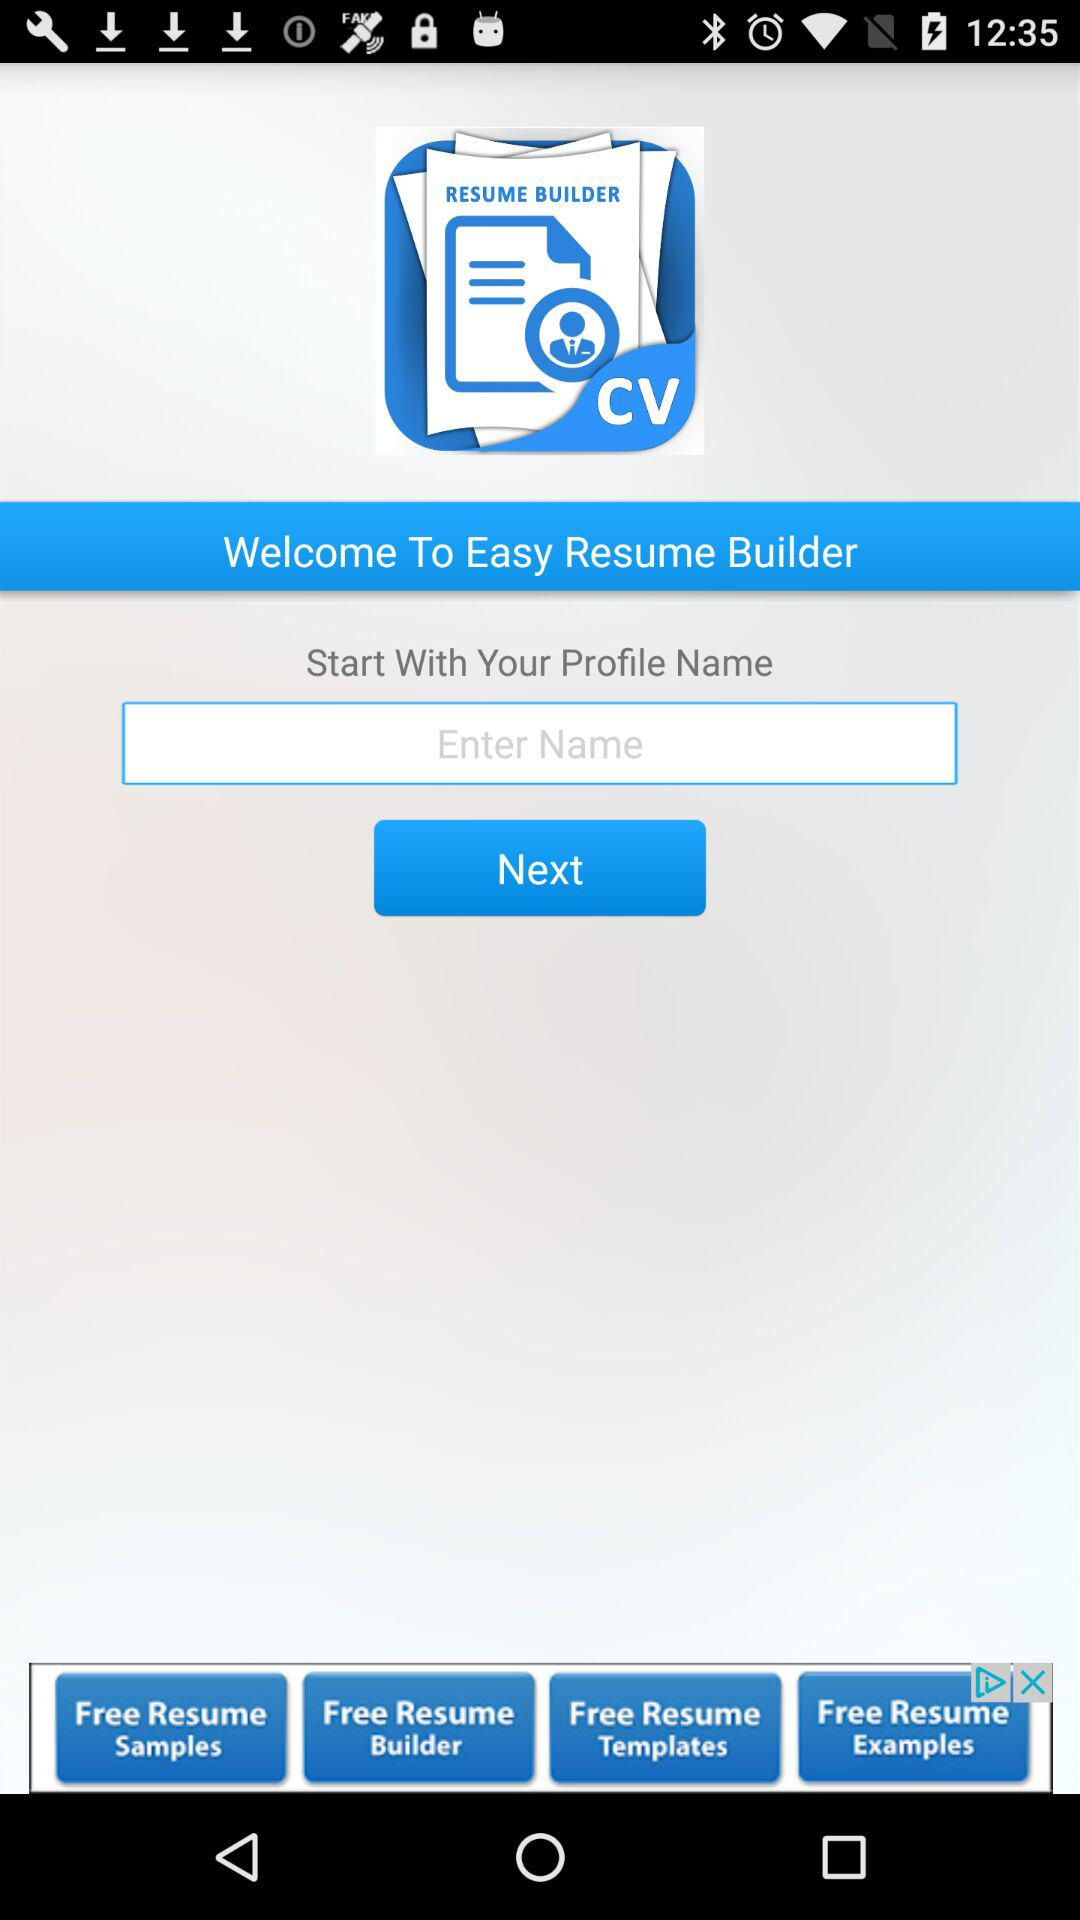What is the name of the application? The name of the application is "Easy Resume Builder". 